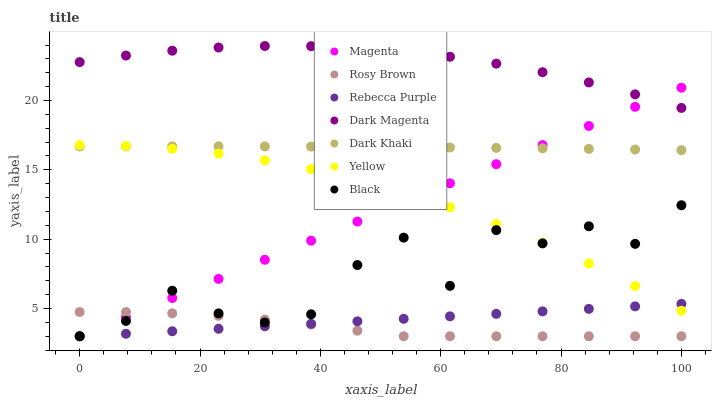Does Rosy Brown have the minimum area under the curve?
Answer yes or no. Yes. Does Dark Magenta have the maximum area under the curve?
Answer yes or no. Yes. Does Yellow have the minimum area under the curve?
Answer yes or no. No. Does Yellow have the maximum area under the curve?
Answer yes or no. No. Is Rebecca Purple the smoothest?
Answer yes or no. Yes. Is Black the roughest?
Answer yes or no. Yes. Is Rosy Brown the smoothest?
Answer yes or no. No. Is Rosy Brown the roughest?
Answer yes or no. No. Does Rosy Brown have the lowest value?
Answer yes or no. Yes. Does Yellow have the lowest value?
Answer yes or no. No. Does Dark Magenta have the highest value?
Answer yes or no. Yes. Does Yellow have the highest value?
Answer yes or no. No. Is Yellow less than Dark Magenta?
Answer yes or no. Yes. Is Dark Magenta greater than Black?
Answer yes or no. Yes. Does Yellow intersect Magenta?
Answer yes or no. Yes. Is Yellow less than Magenta?
Answer yes or no. No. Is Yellow greater than Magenta?
Answer yes or no. No. Does Yellow intersect Dark Magenta?
Answer yes or no. No. 